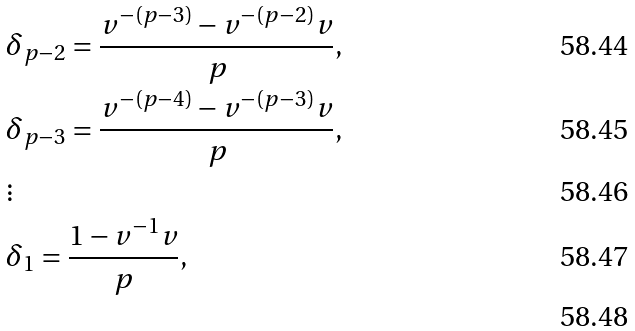<formula> <loc_0><loc_0><loc_500><loc_500>& \delta _ { p - 2 } = \frac { v ^ { - ( p - 3 ) } - v ^ { - ( p - 2 ) } v } { p } , \\ & \delta _ { p - 3 } = \frac { v ^ { - ( p - 4 ) } - v ^ { - ( p - 3 ) } v } { p } , \\ & \vdots \\ & \delta _ { 1 } = \frac { 1 - v ^ { - 1 } v } { p } , \\</formula> 